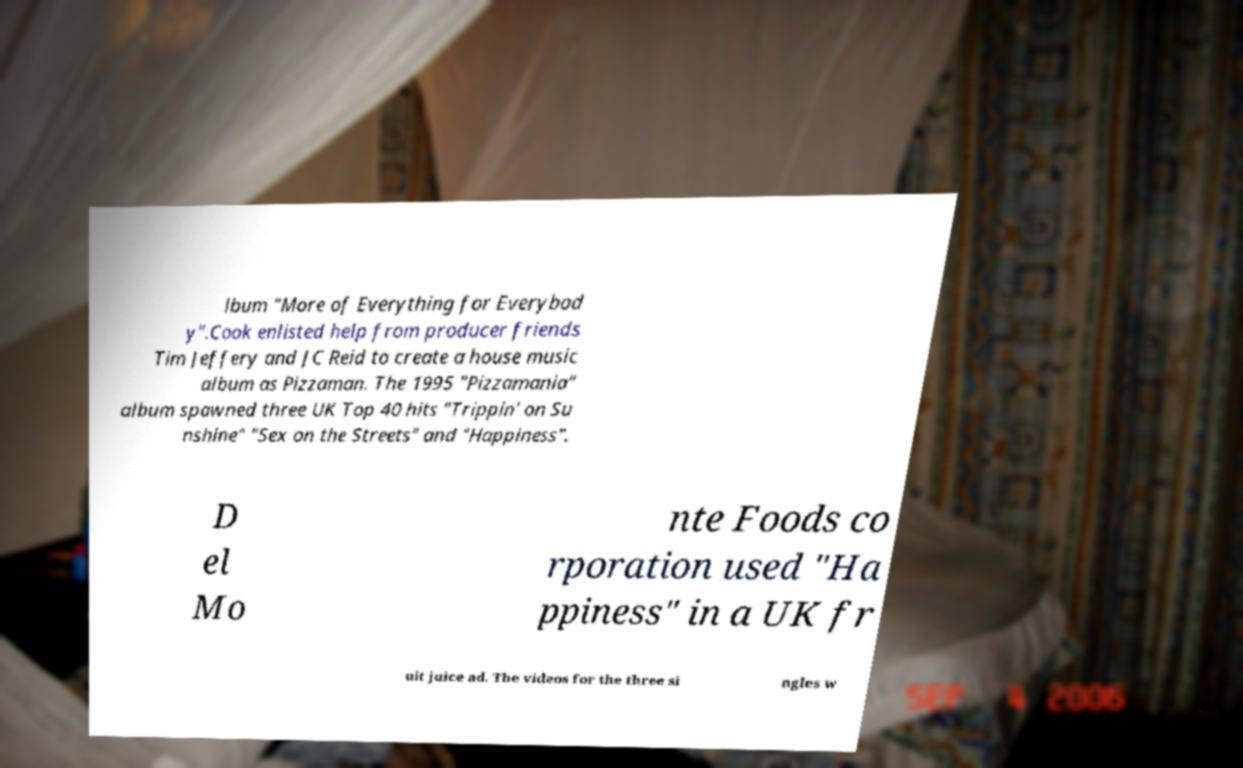Please read and relay the text visible in this image. What does it say? lbum "More of Everything for Everybod y".Cook enlisted help from producer friends Tim Jeffery and JC Reid to create a house music album as Pizzaman. The 1995 "Pizzamania" album spawned three UK Top 40 hits "Trippin' on Su nshine" "Sex on the Streets" and "Happiness". D el Mo nte Foods co rporation used "Ha ppiness" in a UK fr uit juice ad. The videos for the three si ngles w 